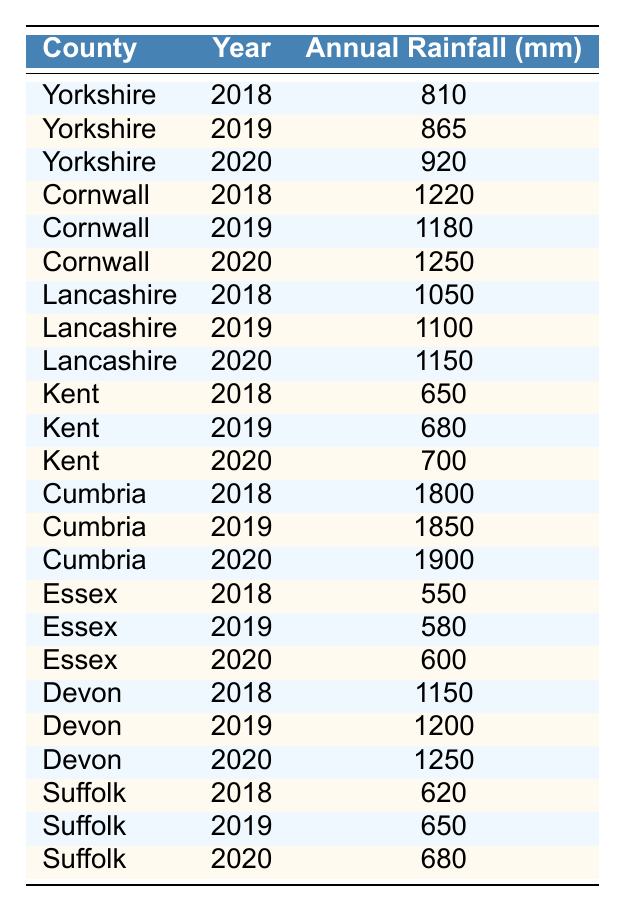What was the annual rainfall in Cornwall in 2020? According to the table, the value listed for Cornwall in 2020 is 1250 mm.
Answer: 1250 mm Which county had the highest annual rainfall in 2019? The table shows that Cornwall had 1180 mm and Cumbria had 1850 mm in 2019. Therefore, Cumbria had the highest rainfall.
Answer: Cumbria What is the average annual rainfall for Essex from 2018 to 2020? For Essex, the yearly rainfall is 550 mm in 2018, 580 mm in 2019, and 600 mm in 2020. Summing these gives 550 + 580 + 600 = 1730 mm; dividing by 3 yields an average of 1730 / 3 = 576.67 mm.
Answer: 576.67 mm Did Kent's annual rainfall increase every year from 2018 to 2020? Checking the data for Kent, the rainfall is 650 mm in 2018, 680 mm in 2019, and 700 mm in 2020, showing that it increased each year.
Answer: Yes How much more rainfall did Cumbria receive in 2020 than Yorkshire? Cumbria's rainfall in 2020 is 1900 mm, and Yorkshire's is 920 mm. The difference is 1900 - 920 = 980 mm.
Answer: 980 mm What was the total annual rainfall recorded for all counties in 2018? Adding the annual rainfall for all counties in 2018: 810 (Yorkshire) + 1220 (Cornwall) + 1050 (Lancashire) + 650 (Kent) + 1800 (Cumbria) + 550 (Essex) + 1150 (Devon) + 620 (Suffolk) = 5850 mm.
Answer: 5850 mm In which year did Devon have the least annual rainfall? The table indicates that Devon’s rainfall was 1150 mm in 2018, 1200 mm in 2019, and 1250 mm in 2020, showing that 1150 mm in 2018 was the lowest.
Answer: 2018 What percentage of annual rainfall in Yorkshire in 2019 does that in Kent in the same year represent? Yorkshire had 865 mm and Kent had 680 mm in 2019. To find the percentage, calculate (680 / 865) * 100, which equals approximately 78.5%.
Answer: 78.5% Which counties received more than 1000 mm of rainfall in 2020? In 2020, Cumbria received 1900 mm, Cornwall received 1250 mm, and Lancashire received 1150 mm. All these values are greater than 1000 mm.
Answer: 3 counties (Cumbria, Cornwall, Lancashire) Was there any county that reported less than 600 mm of rainfall in any of the years represented? Checking all counties, Essex reported 550 mm in 2018, which is less than 600 mm. Thus, there are counties with less than 600 mm.
Answer: Yes 